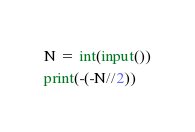Convert code to text. <code><loc_0><loc_0><loc_500><loc_500><_Python_>N = int(input())
print(-(-N//2))</code> 